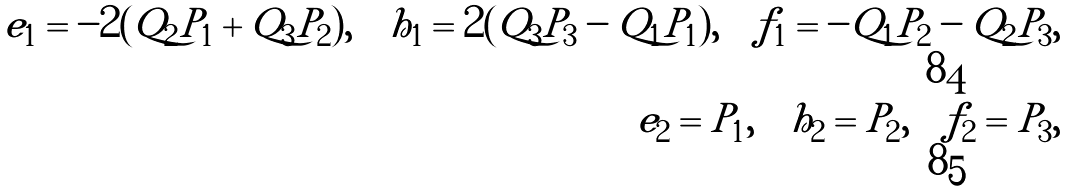Convert formula to latex. <formula><loc_0><loc_0><loc_500><loc_500>e _ { 1 } = - 2 ( Q _ { 2 } P _ { 1 } + Q _ { 3 } P _ { 2 } ) , \quad h _ { 1 } = 2 ( Q _ { 3 } P _ { 3 } - Q _ { 1 } P _ { 1 } ) , \quad f _ { 1 } = - Q _ { 1 } P _ { 2 } - Q _ { 2 } P _ { 3 } , \\ e _ { 2 } = P _ { 1 } , \quad h _ { 2 } = P _ { 2 } , \quad f _ { 2 } = P _ { 3 } ,</formula> 